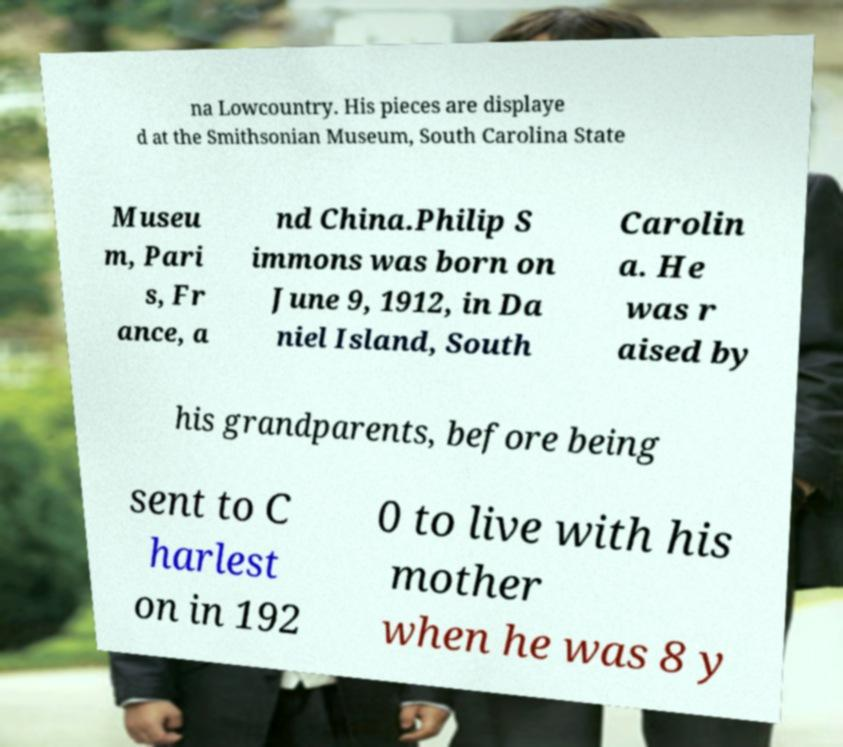Could you assist in decoding the text presented in this image and type it out clearly? na Lowcountry. His pieces are displaye d at the Smithsonian Museum, South Carolina State Museu m, Pari s, Fr ance, a nd China.Philip S immons was born on June 9, 1912, in Da niel Island, South Carolin a. He was r aised by his grandparents, before being sent to C harlest on in 192 0 to live with his mother when he was 8 y 